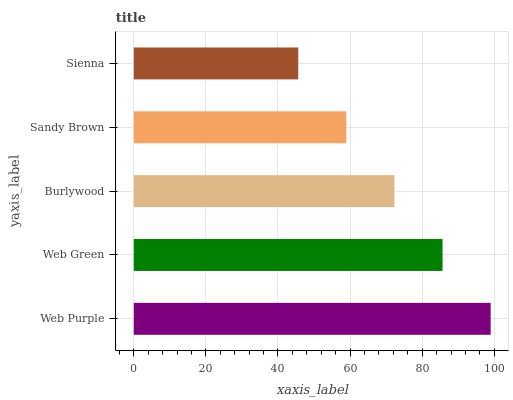Is Sienna the minimum?
Answer yes or no. Yes. Is Web Purple the maximum?
Answer yes or no. Yes. Is Web Green the minimum?
Answer yes or no. No. Is Web Green the maximum?
Answer yes or no. No. Is Web Purple greater than Web Green?
Answer yes or no. Yes. Is Web Green less than Web Purple?
Answer yes or no. Yes. Is Web Green greater than Web Purple?
Answer yes or no. No. Is Web Purple less than Web Green?
Answer yes or no. No. Is Burlywood the high median?
Answer yes or no. Yes. Is Burlywood the low median?
Answer yes or no. Yes. Is Sienna the high median?
Answer yes or no. No. Is Web Green the low median?
Answer yes or no. No. 